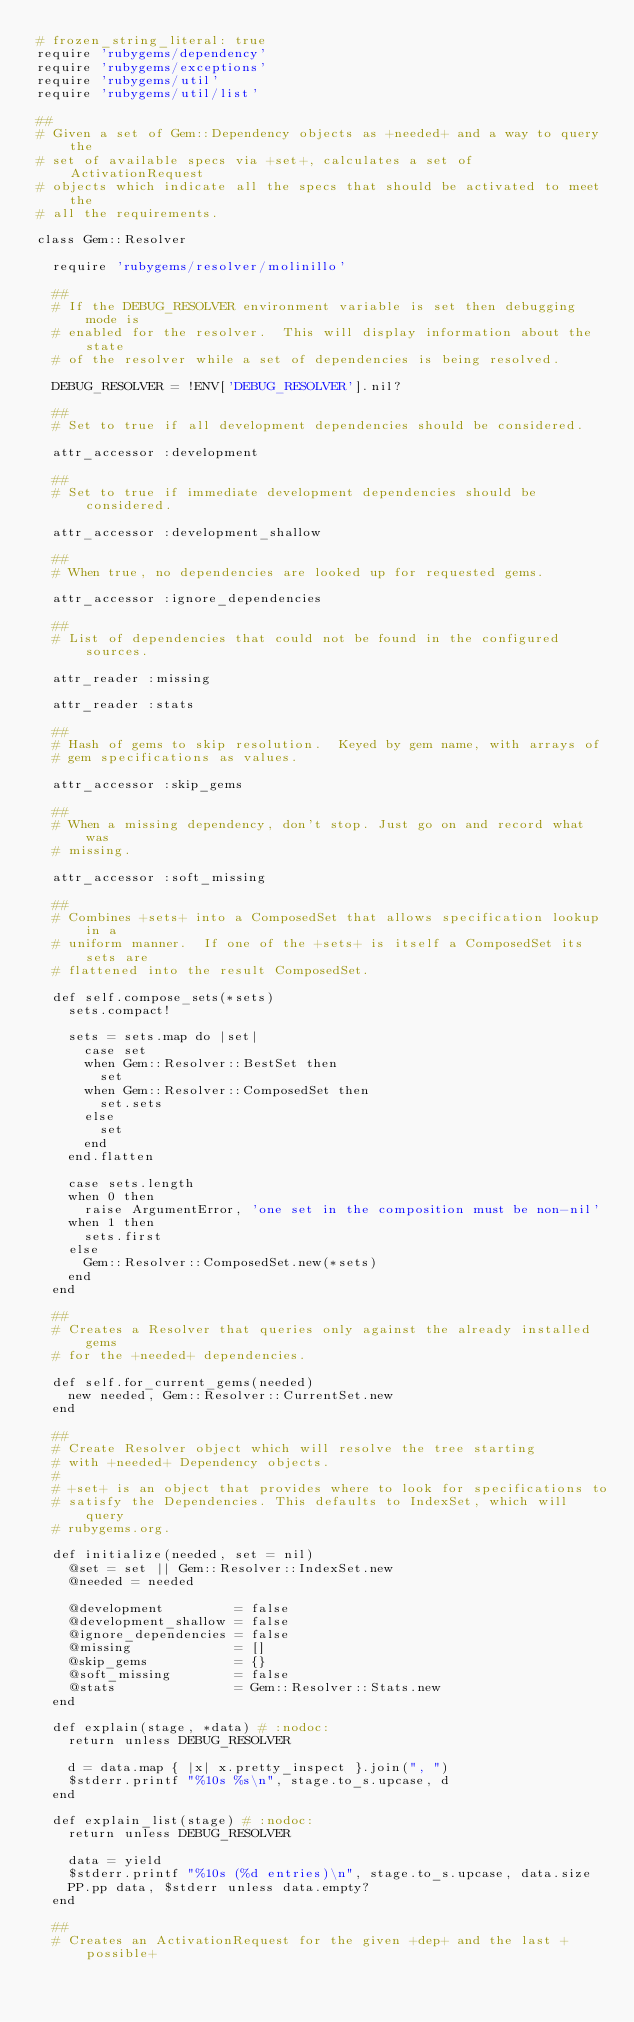<code> <loc_0><loc_0><loc_500><loc_500><_Ruby_># frozen_string_literal: true
require 'rubygems/dependency'
require 'rubygems/exceptions'
require 'rubygems/util'
require 'rubygems/util/list'

##
# Given a set of Gem::Dependency objects as +needed+ and a way to query the
# set of available specs via +set+, calculates a set of ActivationRequest
# objects which indicate all the specs that should be activated to meet the
# all the requirements.

class Gem::Resolver

  require 'rubygems/resolver/molinillo'

  ##
  # If the DEBUG_RESOLVER environment variable is set then debugging mode is
  # enabled for the resolver.  This will display information about the state
  # of the resolver while a set of dependencies is being resolved.

  DEBUG_RESOLVER = !ENV['DEBUG_RESOLVER'].nil?

  ##
  # Set to true if all development dependencies should be considered.

  attr_accessor :development

  ##
  # Set to true if immediate development dependencies should be considered.

  attr_accessor :development_shallow

  ##
  # When true, no dependencies are looked up for requested gems.

  attr_accessor :ignore_dependencies

  ##
  # List of dependencies that could not be found in the configured sources.

  attr_reader :missing

  attr_reader :stats

  ##
  # Hash of gems to skip resolution.  Keyed by gem name, with arrays of
  # gem specifications as values.

  attr_accessor :skip_gems

  ##
  # When a missing dependency, don't stop. Just go on and record what was
  # missing.

  attr_accessor :soft_missing

  ##
  # Combines +sets+ into a ComposedSet that allows specification lookup in a
  # uniform manner.  If one of the +sets+ is itself a ComposedSet its sets are
  # flattened into the result ComposedSet.

  def self.compose_sets(*sets)
    sets.compact!

    sets = sets.map do |set|
      case set
      when Gem::Resolver::BestSet then
        set
      when Gem::Resolver::ComposedSet then
        set.sets
      else
        set
      end
    end.flatten

    case sets.length
    when 0 then
      raise ArgumentError, 'one set in the composition must be non-nil'
    when 1 then
      sets.first
    else
      Gem::Resolver::ComposedSet.new(*sets)
    end
  end

  ##
  # Creates a Resolver that queries only against the already installed gems
  # for the +needed+ dependencies.

  def self.for_current_gems(needed)
    new needed, Gem::Resolver::CurrentSet.new
  end

  ##
  # Create Resolver object which will resolve the tree starting
  # with +needed+ Dependency objects.
  #
  # +set+ is an object that provides where to look for specifications to
  # satisfy the Dependencies. This defaults to IndexSet, which will query
  # rubygems.org.

  def initialize(needed, set = nil)
    @set = set || Gem::Resolver::IndexSet.new
    @needed = needed

    @development         = false
    @development_shallow = false
    @ignore_dependencies = false
    @missing             = []
    @skip_gems           = {}
    @soft_missing        = false
    @stats               = Gem::Resolver::Stats.new
  end

  def explain(stage, *data) # :nodoc:
    return unless DEBUG_RESOLVER

    d = data.map { |x| x.pretty_inspect }.join(", ")
    $stderr.printf "%10s %s\n", stage.to_s.upcase, d
  end

  def explain_list(stage) # :nodoc:
    return unless DEBUG_RESOLVER

    data = yield
    $stderr.printf "%10s (%d entries)\n", stage.to_s.upcase, data.size
    PP.pp data, $stderr unless data.empty?
  end

  ##
  # Creates an ActivationRequest for the given +dep+ and the last +possible+</code> 